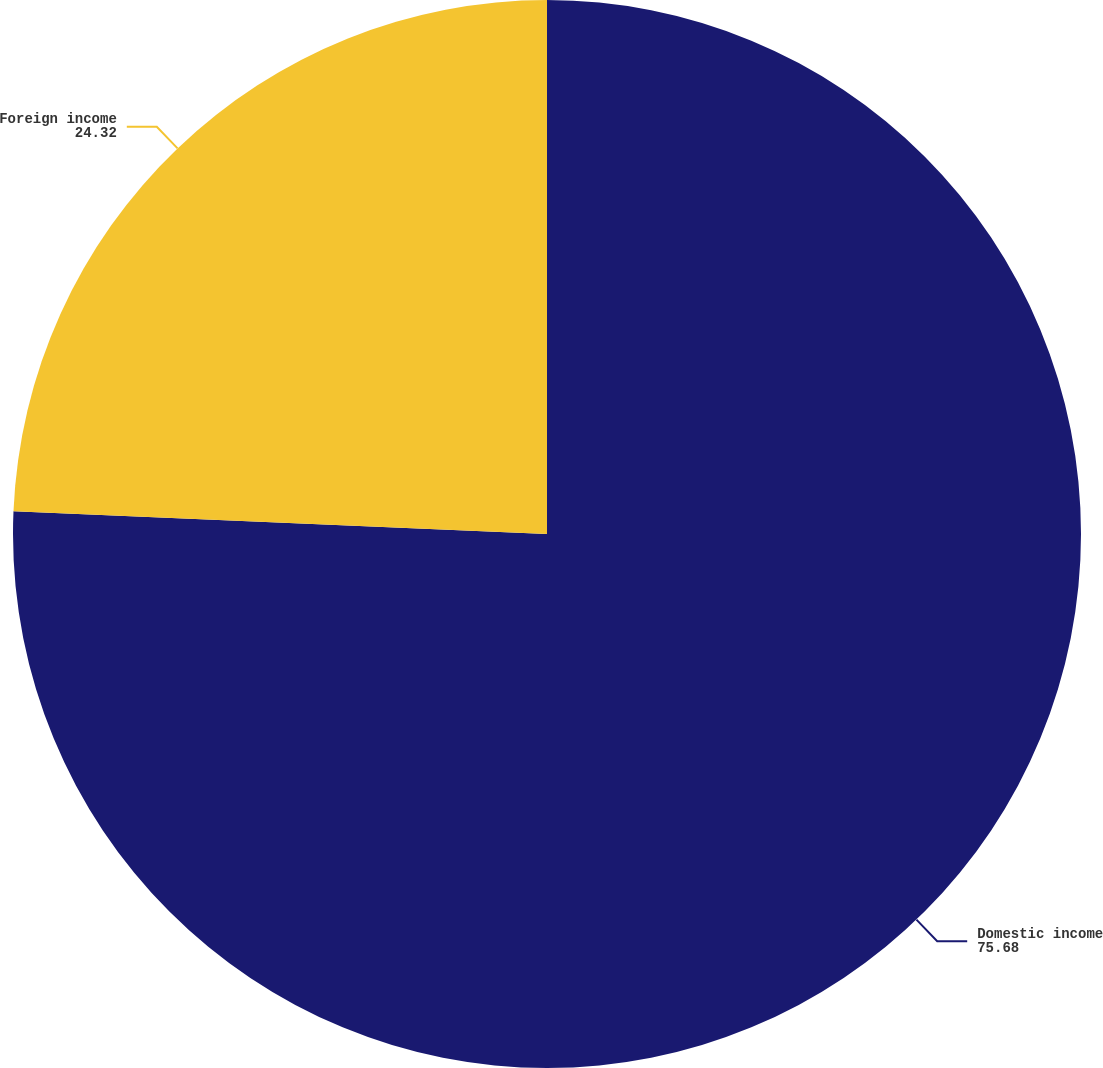<chart> <loc_0><loc_0><loc_500><loc_500><pie_chart><fcel>Domestic income<fcel>Foreign income<nl><fcel>75.68%<fcel>24.32%<nl></chart> 